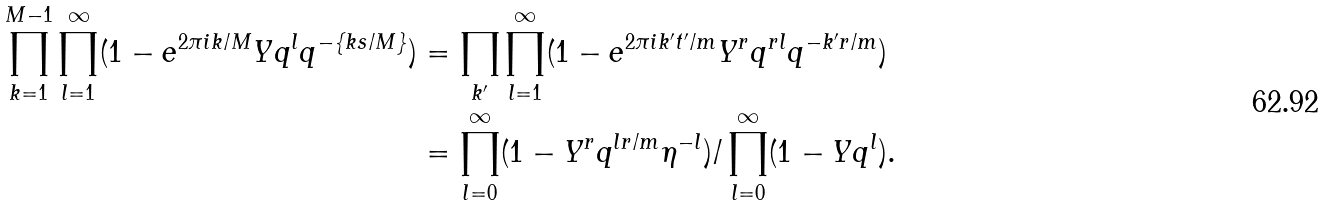Convert formula to latex. <formula><loc_0><loc_0><loc_500><loc_500>\prod _ { k = 1 } ^ { M - 1 } \prod _ { l = 1 } ^ { \infty } ( 1 - e ^ { 2 \pi i k / M } Y q ^ { l } q ^ { - \{ k s / M \} } ) & = \prod _ { k ^ { \prime } } \prod _ { l = 1 } ^ { \infty } ( 1 - e ^ { 2 \pi i k ^ { \prime } t ^ { \prime } / m } Y ^ { r } q ^ { r l } q ^ { - k ^ { \prime } r / m } ) \\ & = \prod _ { l = 0 } ^ { \infty } ( 1 - Y ^ { r } q ^ { l r / m } \eta ^ { - l } ) / \prod _ { l = 0 } ^ { \infty } ( 1 - Y q ^ { l } ) .</formula> 